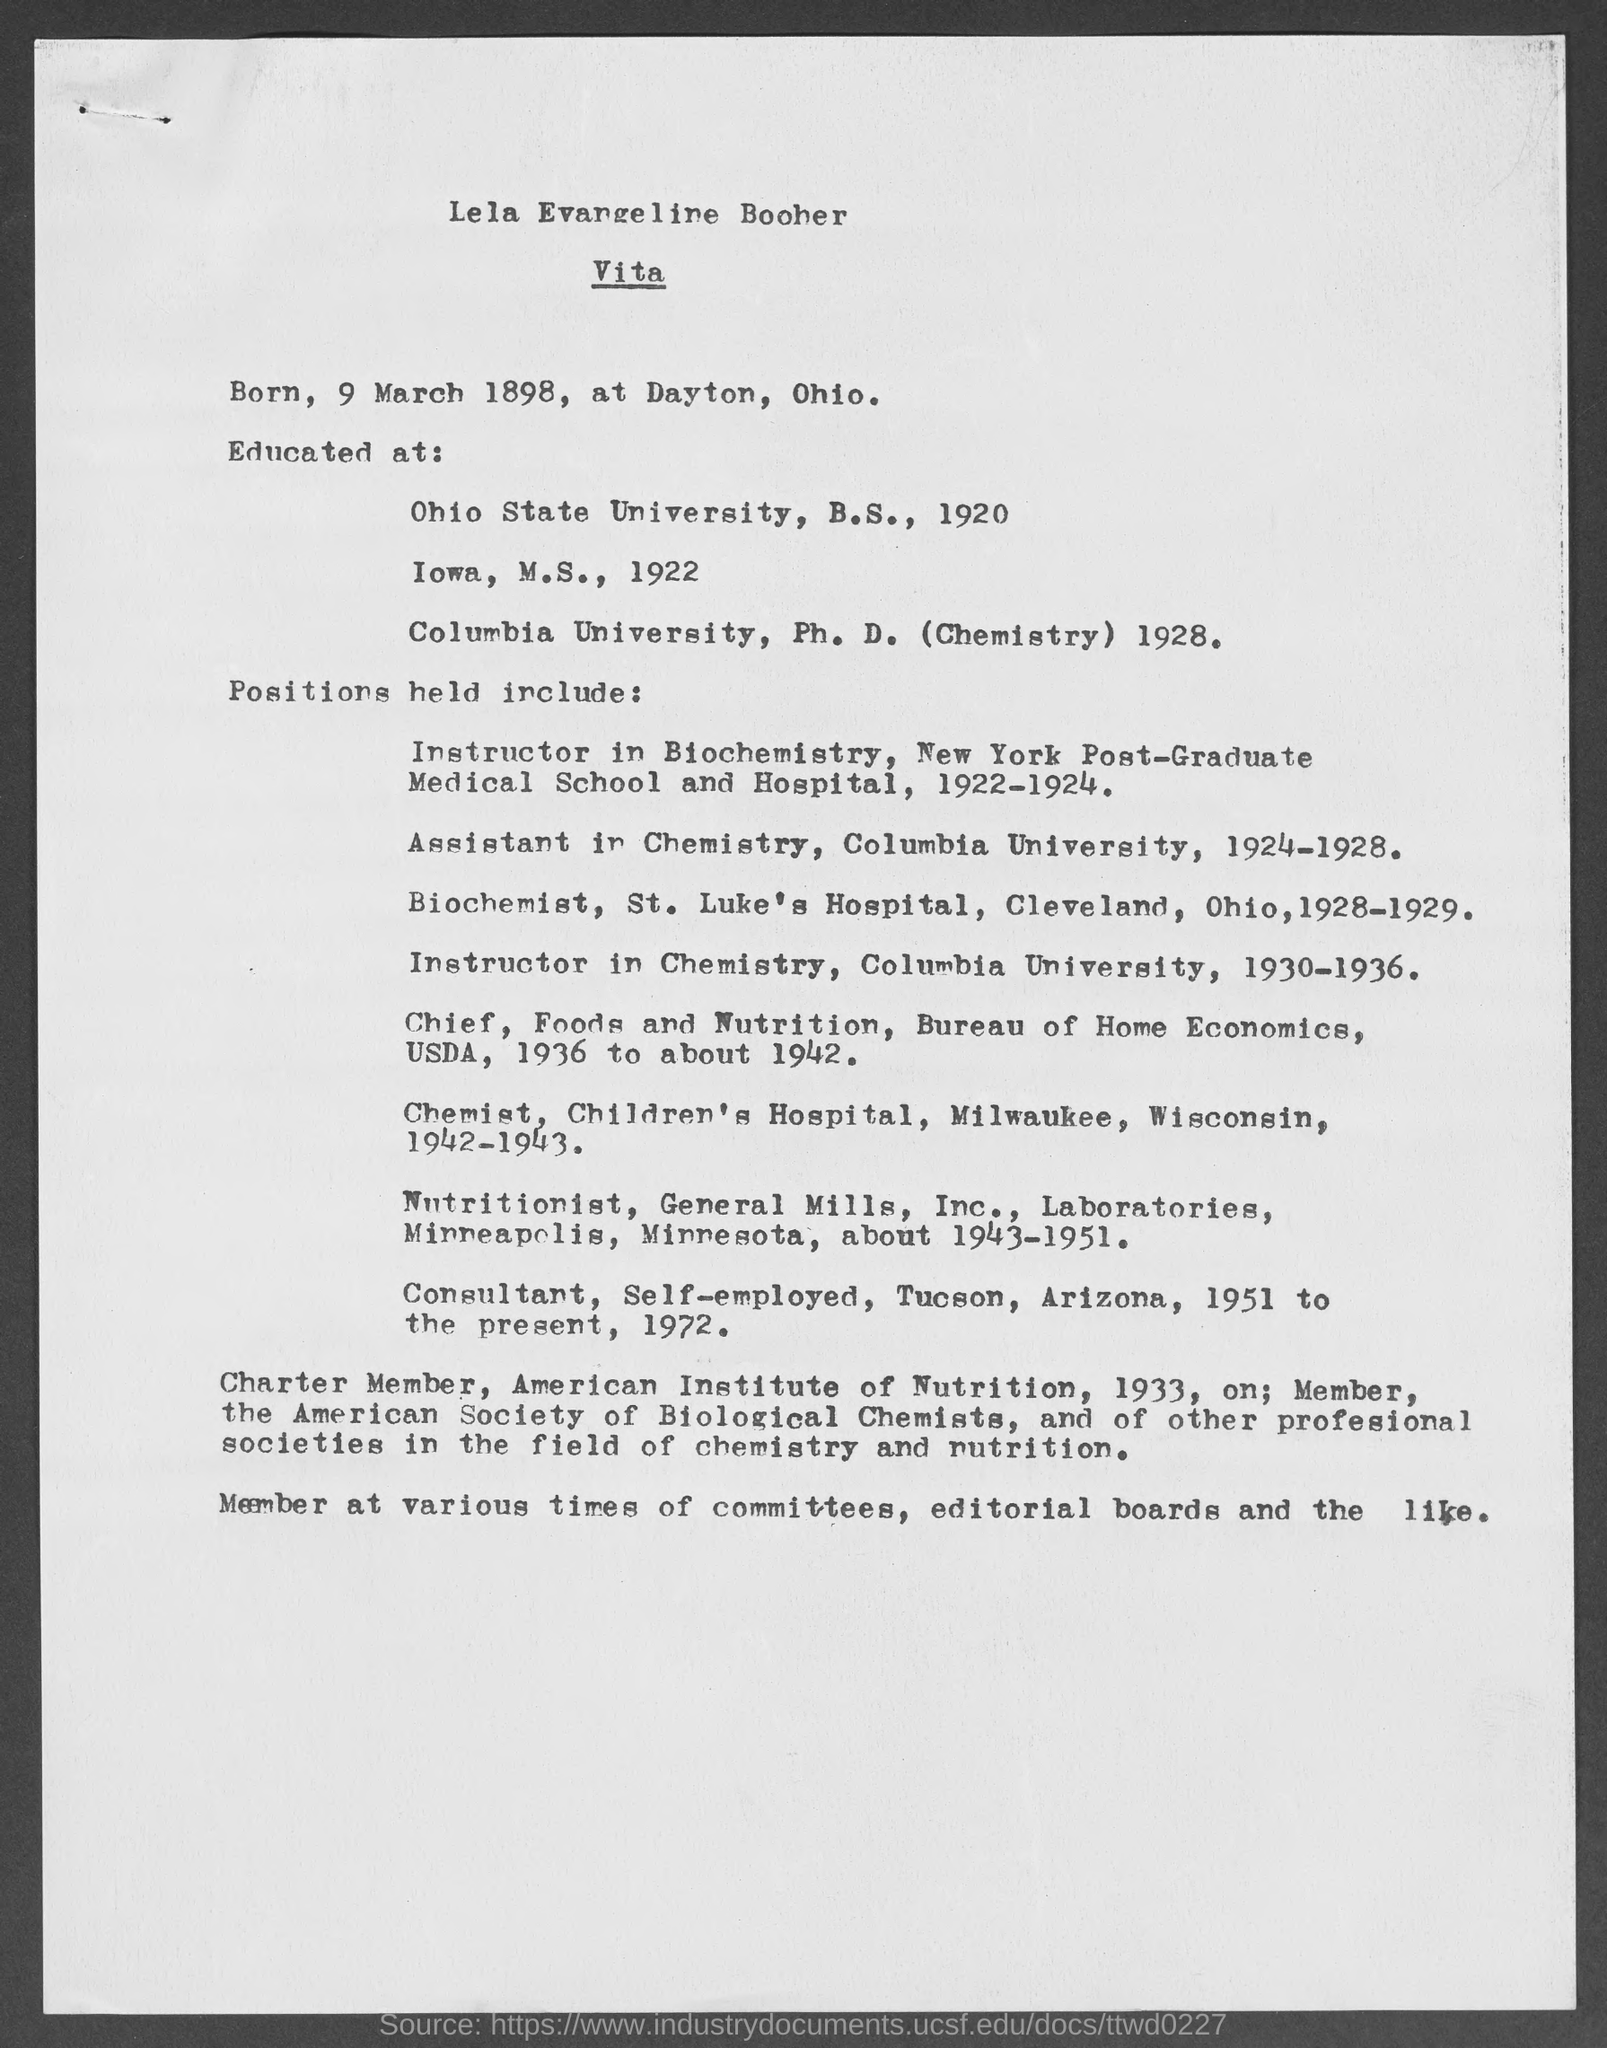What is lela evangeline boober's date of birth?
Your answer should be very brief. 9 March 1898. What is the place of birth of lela evangeline boober?
Offer a very short reply. Dayton, Ohio. From which university did lela evangeline boober complete her ph.d?
Your answer should be compact. Columbia University. From which university did lela evangeline boober complete her b.s?
Keep it short and to the point. Ohio State University. In which year did Lela Evangeline Boober complete her M.S?
Your answer should be compact. 1922. In which year did Lela Evangeline Boober complete her B.S?
Your response must be concise. 1920. In which year did Lela Evangeline Boober complete her Ph.D?
Give a very brief answer. 1928. What is lela evangeline boober's major in ph.d?
Keep it short and to the point. Chemistry. In which term did lela evangeline held position of instructor in biochemistry, new york, post graduate medical school and hospital?
Make the answer very short. 1922-1924. 